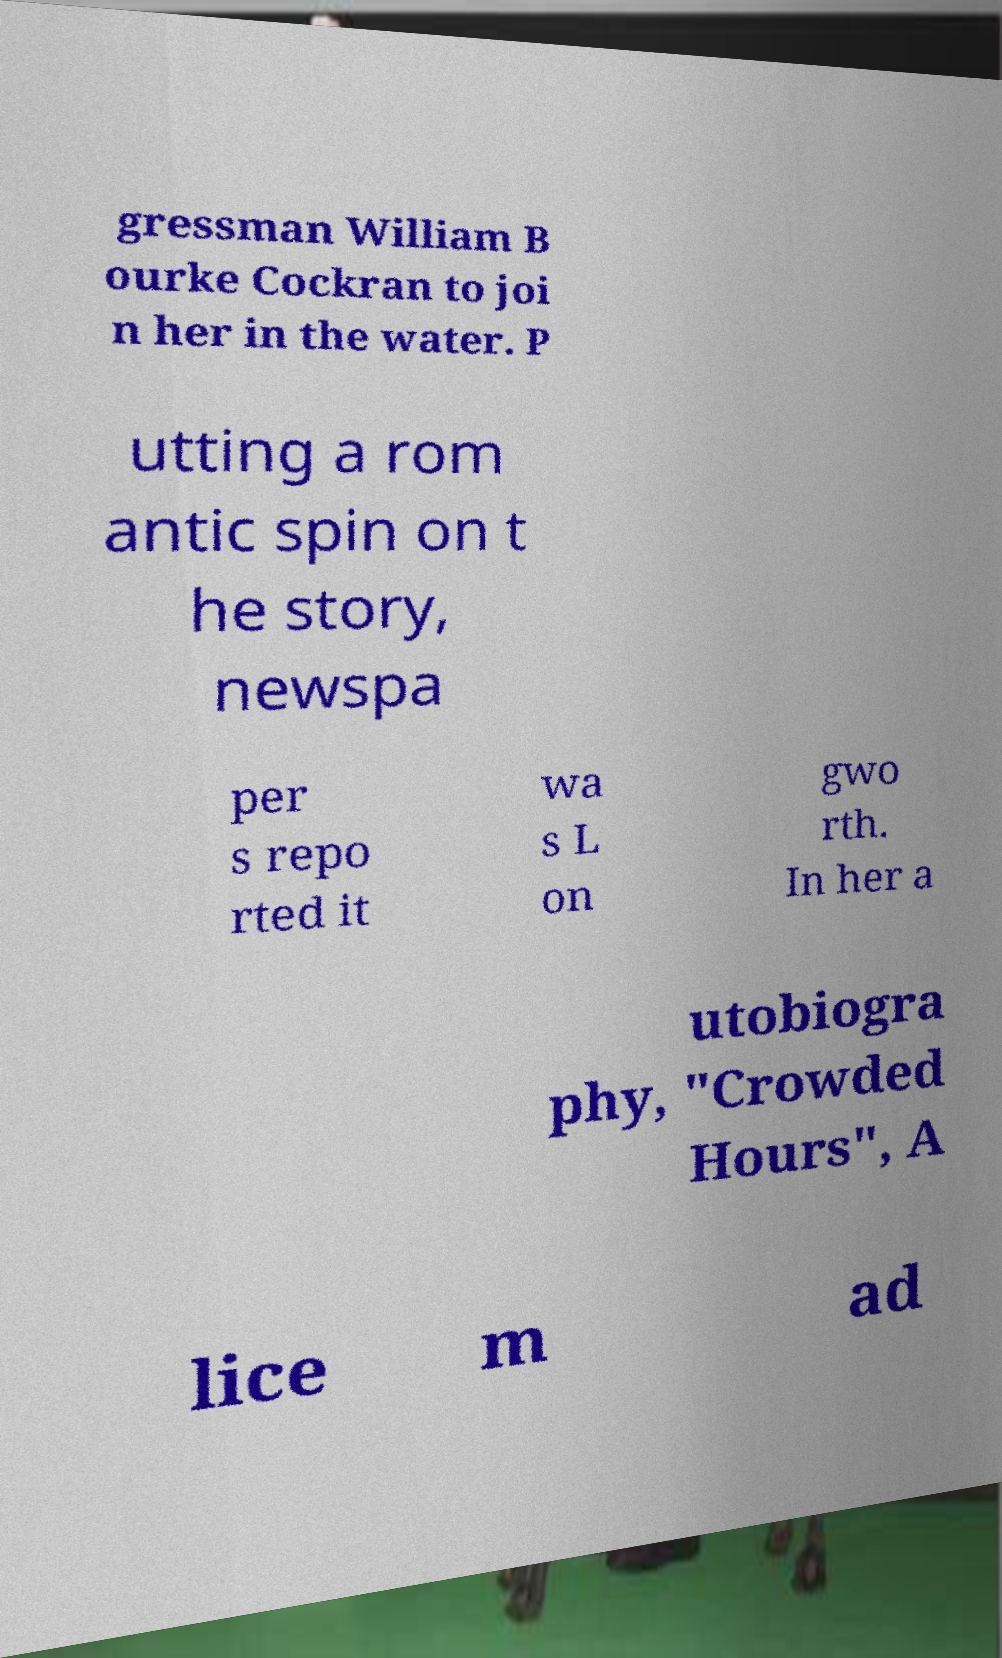Please identify and transcribe the text found in this image. gressman William B ourke Cockran to joi n her in the water. P utting a rom antic spin on t he story, newspa per s repo rted it wa s L on gwo rth. In her a utobiogra phy, "Crowded Hours", A lice m ad 